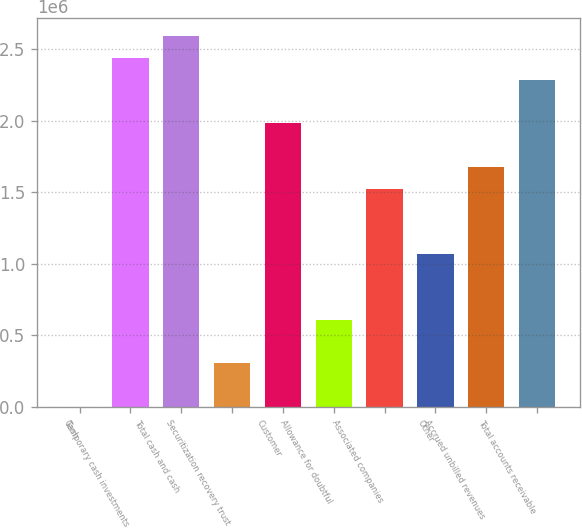<chart> <loc_0><loc_0><loc_500><loc_500><bar_chart><fcel>Cash<fcel>Temporary cash investments<fcel>Total cash and cash<fcel>Securitization recovery trust<fcel>Customer<fcel>Allowance for doubtful<fcel>Associated companies<fcel>Other<fcel>Accrued unbilled revenues<fcel>Total accounts receivable<nl><fcel>28<fcel>2.43889e+06<fcel>2.59132e+06<fcel>304886<fcel>1.9816e+06<fcel>609744<fcel>1.52432e+06<fcel>1.06703e+06<fcel>1.67675e+06<fcel>2.28646e+06<nl></chart> 